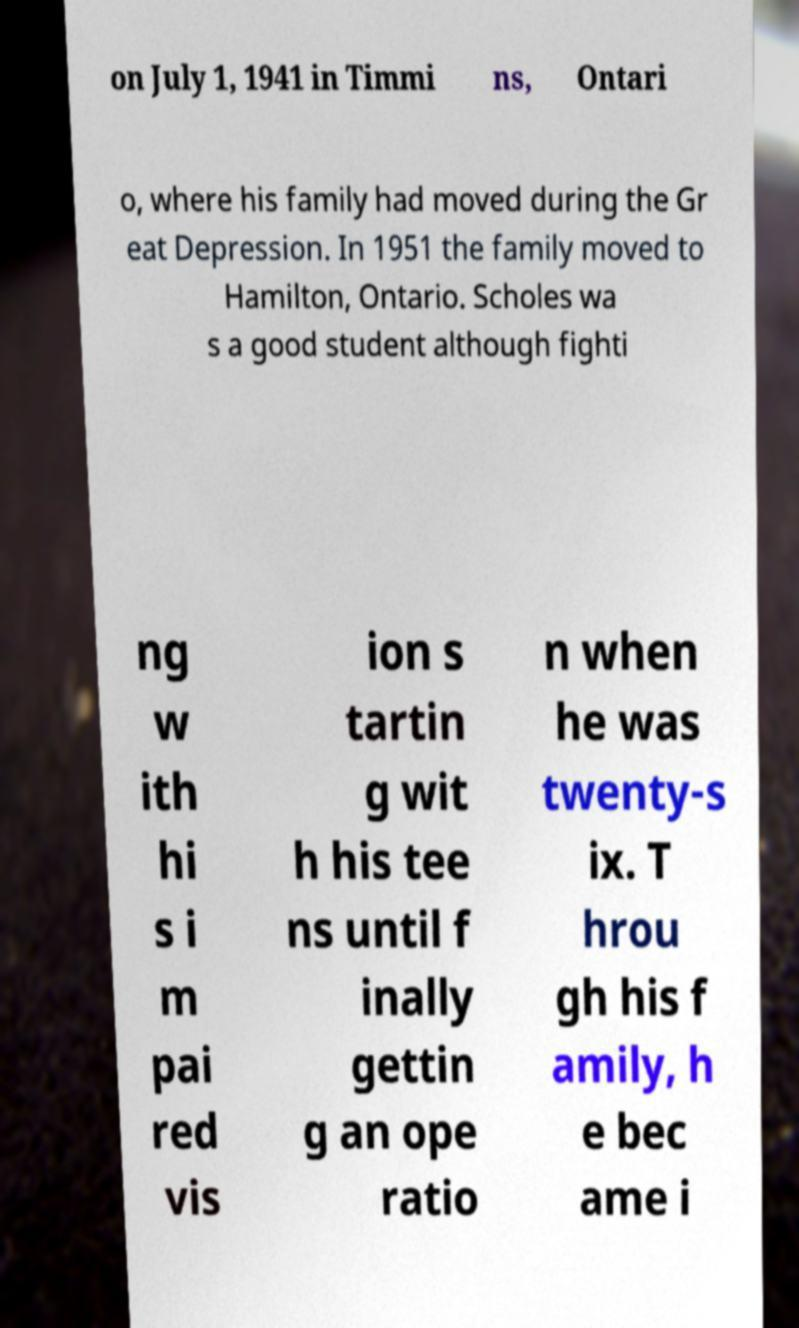Can you accurately transcribe the text from the provided image for me? on July 1, 1941 in Timmi ns, Ontari o, where his family had moved during the Gr eat Depression. In 1951 the family moved to Hamilton, Ontario. Scholes wa s a good student although fighti ng w ith hi s i m pai red vis ion s tartin g wit h his tee ns until f inally gettin g an ope ratio n when he was twenty-s ix. T hrou gh his f amily, h e bec ame i 